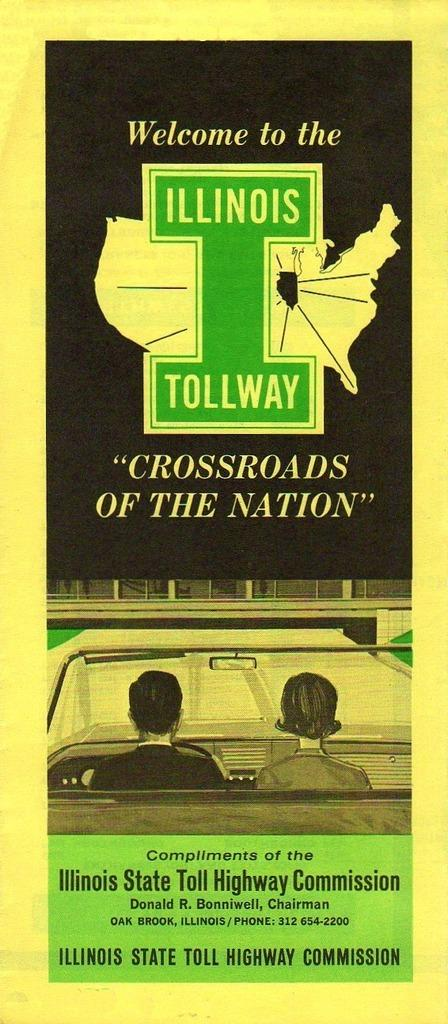What is featured on the poster in the image? Unfortunately, the facts provided do not specify what is on the poster. However, we can confirm that there is a poster in the image. What are the two people in the image doing? The facts provided mention that there are two people in a vehicle in the image. We cannot determine their specific actions, but we know they are inside a vehicle. What types of objects can be seen in the image? The facts provided mention that there are objects visible in the image. However, we cannot specify the exact objects without more information. What does the text in the image say? The facts provided mention that there is text present in the image. However, we cannot determine the exact text without more information. How many cannons are visible on the ground in the image? There are no cannons visible on the ground in the image. What type of pear is being held by one of the people in the vehicle? There is no pear present in the image. 